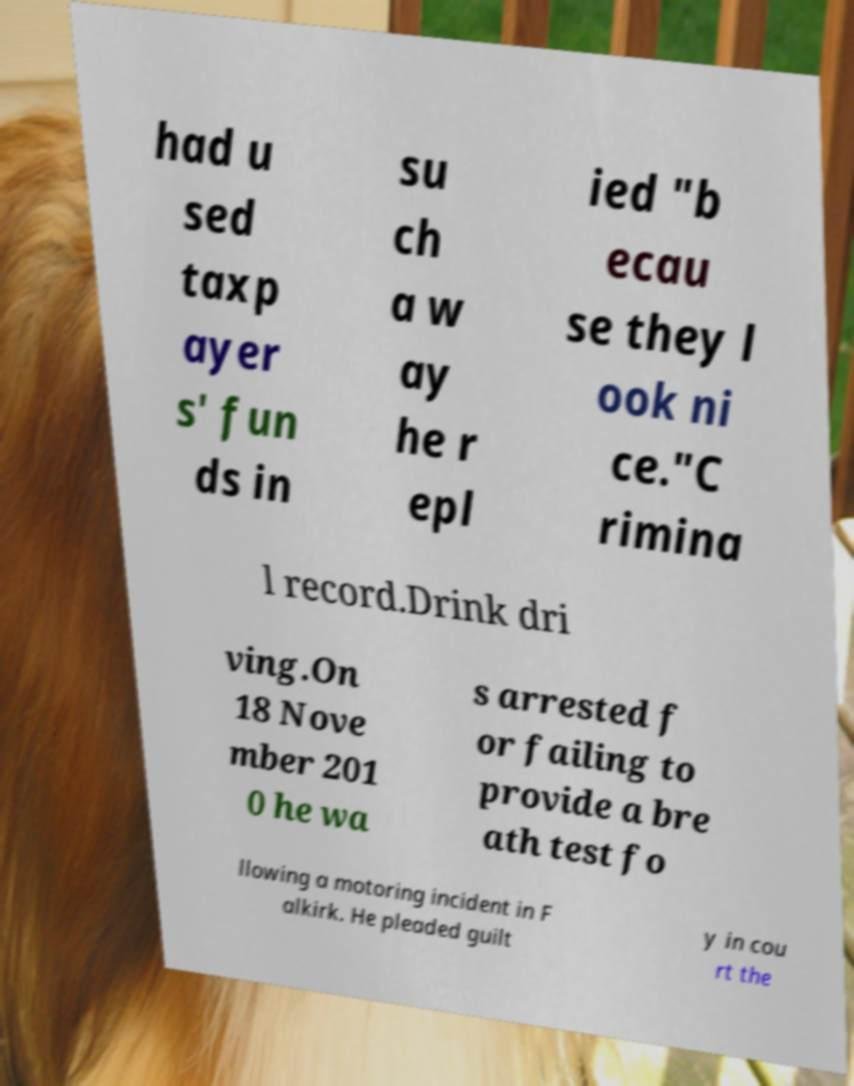Could you extract and type out the text from this image? had u sed taxp ayer s' fun ds in su ch a w ay he r epl ied "b ecau se they l ook ni ce."C rimina l record.Drink dri ving.On 18 Nove mber 201 0 he wa s arrested f or failing to provide a bre ath test fo llowing a motoring incident in F alkirk. He pleaded guilt y in cou rt the 